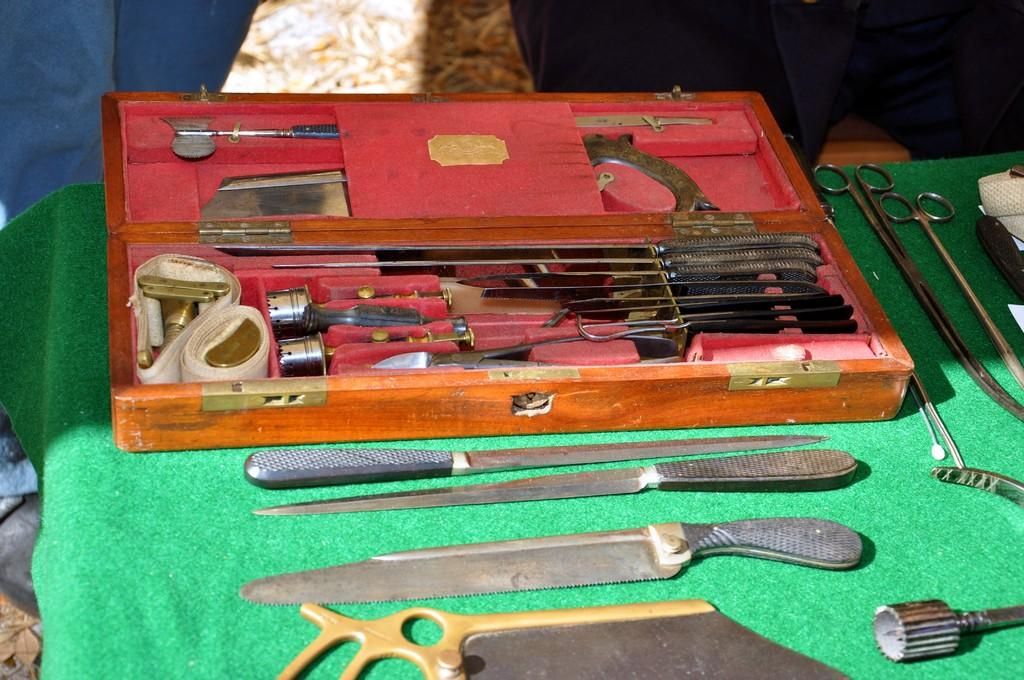What is located in the center of the image? There is a table in the center of the image. What is covering the table? There is a cloth on the table. What objects can be seen on the table? There is a box, a knife, and scissors on the table. Are there any other objects on the table? Yes, there are other objects on the table. What type of police car can be seen driving through the rainstorm in the image? There is no police car or rainstorm present in the image; it features a table with various objects on it. 